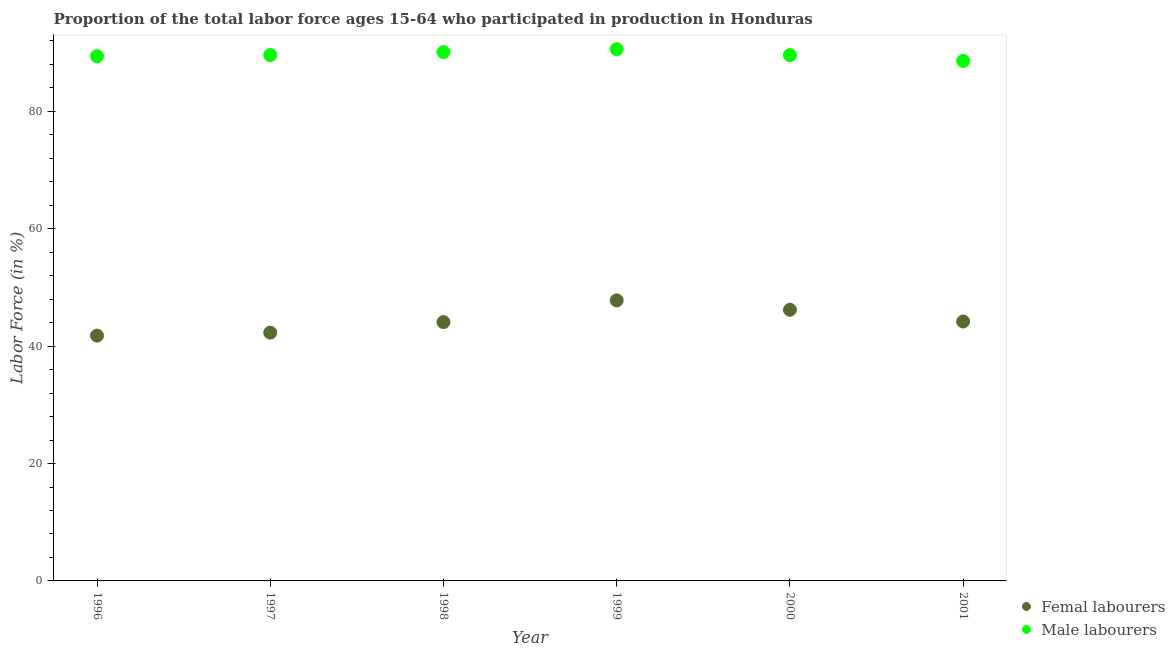What is the percentage of male labour force in 2000?
Give a very brief answer. 89.6. Across all years, what is the maximum percentage of male labour force?
Offer a terse response. 90.6. Across all years, what is the minimum percentage of male labour force?
Your response must be concise. 88.6. What is the total percentage of female labor force in the graph?
Ensure brevity in your answer.  266.4. What is the difference between the percentage of female labor force in 1997 and that in 1999?
Offer a very short reply. -5.5. What is the difference between the percentage of male labour force in 2001 and the percentage of female labor force in 2000?
Make the answer very short. 42.4. What is the average percentage of female labor force per year?
Ensure brevity in your answer.  44.4. In the year 1998, what is the difference between the percentage of male labour force and percentage of female labor force?
Make the answer very short. 46. What is the ratio of the percentage of female labor force in 1996 to that in 1997?
Offer a terse response. 0.99. Is the percentage of female labor force in 1997 less than that in 2001?
Make the answer very short. Yes. What is the difference between the highest and the second highest percentage of female labor force?
Make the answer very short. 1.6. Is the percentage of female labor force strictly greater than the percentage of male labour force over the years?
Provide a succinct answer. No. How many dotlines are there?
Give a very brief answer. 2. What is the difference between two consecutive major ticks on the Y-axis?
Your response must be concise. 20. Are the values on the major ticks of Y-axis written in scientific E-notation?
Ensure brevity in your answer.  No. Does the graph contain grids?
Keep it short and to the point. No. Where does the legend appear in the graph?
Make the answer very short. Bottom right. How many legend labels are there?
Your answer should be very brief. 2. What is the title of the graph?
Your answer should be very brief. Proportion of the total labor force ages 15-64 who participated in production in Honduras. What is the Labor Force (in %) of Femal labourers in 1996?
Your answer should be very brief. 41.8. What is the Labor Force (in %) in Male labourers in 1996?
Give a very brief answer. 89.4. What is the Labor Force (in %) of Femal labourers in 1997?
Your response must be concise. 42.3. What is the Labor Force (in %) in Male labourers in 1997?
Make the answer very short. 89.6. What is the Labor Force (in %) of Femal labourers in 1998?
Your response must be concise. 44.1. What is the Labor Force (in %) of Male labourers in 1998?
Offer a terse response. 90.1. What is the Labor Force (in %) in Femal labourers in 1999?
Make the answer very short. 47.8. What is the Labor Force (in %) in Male labourers in 1999?
Offer a terse response. 90.6. What is the Labor Force (in %) of Femal labourers in 2000?
Make the answer very short. 46.2. What is the Labor Force (in %) in Male labourers in 2000?
Your answer should be compact. 89.6. What is the Labor Force (in %) of Femal labourers in 2001?
Your answer should be compact. 44.2. What is the Labor Force (in %) in Male labourers in 2001?
Your answer should be very brief. 88.6. Across all years, what is the maximum Labor Force (in %) in Femal labourers?
Your answer should be very brief. 47.8. Across all years, what is the maximum Labor Force (in %) in Male labourers?
Provide a succinct answer. 90.6. Across all years, what is the minimum Labor Force (in %) in Femal labourers?
Your answer should be very brief. 41.8. Across all years, what is the minimum Labor Force (in %) of Male labourers?
Make the answer very short. 88.6. What is the total Labor Force (in %) in Femal labourers in the graph?
Offer a very short reply. 266.4. What is the total Labor Force (in %) in Male labourers in the graph?
Offer a terse response. 537.9. What is the difference between the Labor Force (in %) in Femal labourers in 1996 and that in 1998?
Give a very brief answer. -2.3. What is the difference between the Labor Force (in %) in Male labourers in 1996 and that in 1998?
Offer a very short reply. -0.7. What is the difference between the Labor Force (in %) of Femal labourers in 1996 and that in 1999?
Your response must be concise. -6. What is the difference between the Labor Force (in %) of Male labourers in 1996 and that in 1999?
Give a very brief answer. -1.2. What is the difference between the Labor Force (in %) in Femal labourers in 1996 and that in 2000?
Give a very brief answer. -4.4. What is the difference between the Labor Force (in %) of Male labourers in 1997 and that in 1999?
Give a very brief answer. -1. What is the difference between the Labor Force (in %) in Male labourers in 1997 and that in 2000?
Your response must be concise. 0. What is the difference between the Labor Force (in %) in Male labourers in 1997 and that in 2001?
Keep it short and to the point. 1. What is the difference between the Labor Force (in %) in Femal labourers in 1998 and that in 2001?
Offer a terse response. -0.1. What is the difference between the Labor Force (in %) of Male labourers in 1999 and that in 2001?
Your answer should be compact. 2. What is the difference between the Labor Force (in %) of Femal labourers in 1996 and the Labor Force (in %) of Male labourers in 1997?
Provide a succinct answer. -47.8. What is the difference between the Labor Force (in %) of Femal labourers in 1996 and the Labor Force (in %) of Male labourers in 1998?
Keep it short and to the point. -48.3. What is the difference between the Labor Force (in %) of Femal labourers in 1996 and the Labor Force (in %) of Male labourers in 1999?
Offer a very short reply. -48.8. What is the difference between the Labor Force (in %) of Femal labourers in 1996 and the Labor Force (in %) of Male labourers in 2000?
Provide a short and direct response. -47.8. What is the difference between the Labor Force (in %) in Femal labourers in 1996 and the Labor Force (in %) in Male labourers in 2001?
Your answer should be very brief. -46.8. What is the difference between the Labor Force (in %) in Femal labourers in 1997 and the Labor Force (in %) in Male labourers in 1998?
Provide a succinct answer. -47.8. What is the difference between the Labor Force (in %) of Femal labourers in 1997 and the Labor Force (in %) of Male labourers in 1999?
Your response must be concise. -48.3. What is the difference between the Labor Force (in %) of Femal labourers in 1997 and the Labor Force (in %) of Male labourers in 2000?
Keep it short and to the point. -47.3. What is the difference between the Labor Force (in %) of Femal labourers in 1997 and the Labor Force (in %) of Male labourers in 2001?
Provide a short and direct response. -46.3. What is the difference between the Labor Force (in %) of Femal labourers in 1998 and the Labor Force (in %) of Male labourers in 1999?
Give a very brief answer. -46.5. What is the difference between the Labor Force (in %) in Femal labourers in 1998 and the Labor Force (in %) in Male labourers in 2000?
Your response must be concise. -45.5. What is the difference between the Labor Force (in %) in Femal labourers in 1998 and the Labor Force (in %) in Male labourers in 2001?
Make the answer very short. -44.5. What is the difference between the Labor Force (in %) of Femal labourers in 1999 and the Labor Force (in %) of Male labourers in 2000?
Provide a short and direct response. -41.8. What is the difference between the Labor Force (in %) in Femal labourers in 1999 and the Labor Force (in %) in Male labourers in 2001?
Your answer should be compact. -40.8. What is the difference between the Labor Force (in %) of Femal labourers in 2000 and the Labor Force (in %) of Male labourers in 2001?
Offer a terse response. -42.4. What is the average Labor Force (in %) of Femal labourers per year?
Offer a very short reply. 44.4. What is the average Labor Force (in %) in Male labourers per year?
Provide a short and direct response. 89.65. In the year 1996, what is the difference between the Labor Force (in %) in Femal labourers and Labor Force (in %) in Male labourers?
Your response must be concise. -47.6. In the year 1997, what is the difference between the Labor Force (in %) in Femal labourers and Labor Force (in %) in Male labourers?
Offer a terse response. -47.3. In the year 1998, what is the difference between the Labor Force (in %) in Femal labourers and Labor Force (in %) in Male labourers?
Make the answer very short. -46. In the year 1999, what is the difference between the Labor Force (in %) of Femal labourers and Labor Force (in %) of Male labourers?
Keep it short and to the point. -42.8. In the year 2000, what is the difference between the Labor Force (in %) in Femal labourers and Labor Force (in %) in Male labourers?
Your response must be concise. -43.4. In the year 2001, what is the difference between the Labor Force (in %) of Femal labourers and Labor Force (in %) of Male labourers?
Your response must be concise. -44.4. What is the ratio of the Labor Force (in %) in Femal labourers in 1996 to that in 1997?
Your answer should be very brief. 0.99. What is the ratio of the Labor Force (in %) in Femal labourers in 1996 to that in 1998?
Provide a succinct answer. 0.95. What is the ratio of the Labor Force (in %) of Femal labourers in 1996 to that in 1999?
Your answer should be very brief. 0.87. What is the ratio of the Labor Force (in %) in Male labourers in 1996 to that in 1999?
Offer a terse response. 0.99. What is the ratio of the Labor Force (in %) in Femal labourers in 1996 to that in 2000?
Your answer should be very brief. 0.9. What is the ratio of the Labor Force (in %) of Femal labourers in 1996 to that in 2001?
Make the answer very short. 0.95. What is the ratio of the Labor Force (in %) in Femal labourers in 1997 to that in 1998?
Offer a terse response. 0.96. What is the ratio of the Labor Force (in %) of Femal labourers in 1997 to that in 1999?
Keep it short and to the point. 0.88. What is the ratio of the Labor Force (in %) in Femal labourers in 1997 to that in 2000?
Offer a very short reply. 0.92. What is the ratio of the Labor Force (in %) of Femal labourers in 1997 to that in 2001?
Provide a short and direct response. 0.96. What is the ratio of the Labor Force (in %) of Male labourers in 1997 to that in 2001?
Give a very brief answer. 1.01. What is the ratio of the Labor Force (in %) in Femal labourers in 1998 to that in 1999?
Provide a succinct answer. 0.92. What is the ratio of the Labor Force (in %) of Femal labourers in 1998 to that in 2000?
Your answer should be very brief. 0.95. What is the ratio of the Labor Force (in %) in Male labourers in 1998 to that in 2000?
Provide a short and direct response. 1.01. What is the ratio of the Labor Force (in %) in Femal labourers in 1998 to that in 2001?
Your response must be concise. 1. What is the ratio of the Labor Force (in %) of Male labourers in 1998 to that in 2001?
Provide a short and direct response. 1.02. What is the ratio of the Labor Force (in %) in Femal labourers in 1999 to that in 2000?
Your answer should be very brief. 1.03. What is the ratio of the Labor Force (in %) in Male labourers in 1999 to that in 2000?
Your response must be concise. 1.01. What is the ratio of the Labor Force (in %) in Femal labourers in 1999 to that in 2001?
Make the answer very short. 1.08. What is the ratio of the Labor Force (in %) of Male labourers in 1999 to that in 2001?
Make the answer very short. 1.02. What is the ratio of the Labor Force (in %) of Femal labourers in 2000 to that in 2001?
Your response must be concise. 1.05. What is the ratio of the Labor Force (in %) in Male labourers in 2000 to that in 2001?
Make the answer very short. 1.01. 